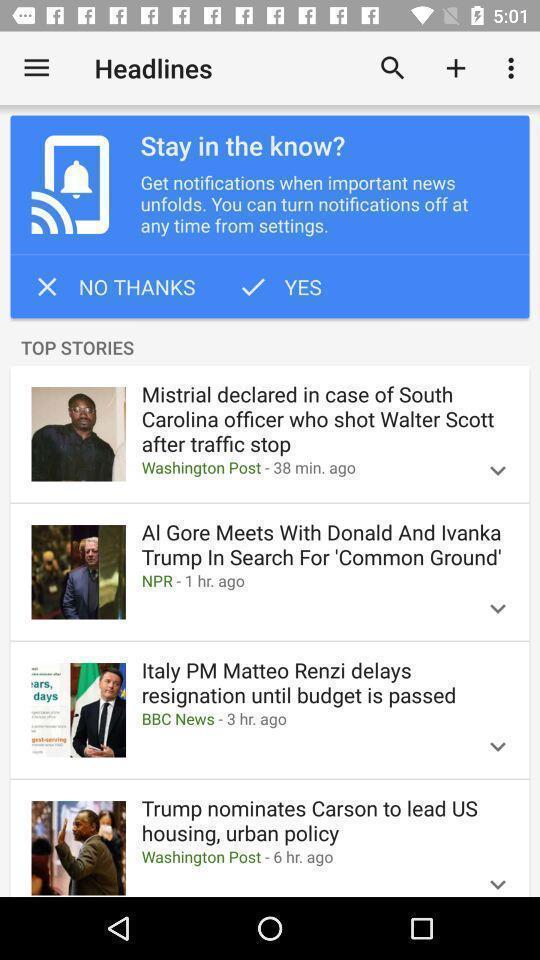Please provide a description for this image. Page showing headlines on news app. 